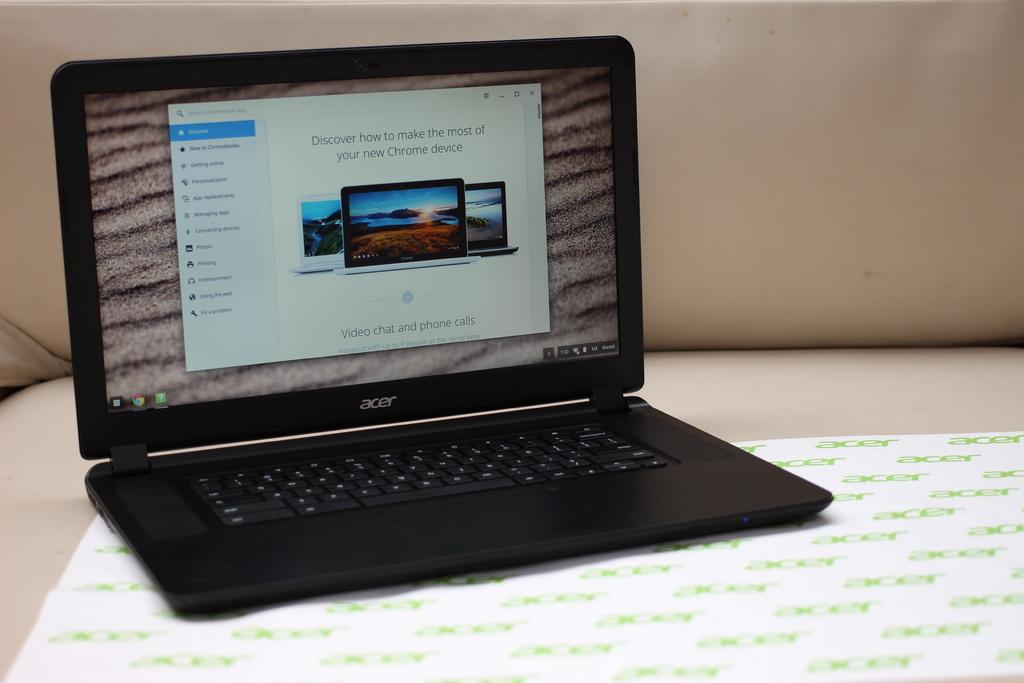Provide a one-sentence caption for the provided image. An Acer laptop that is open to a page where you can discover how to make the most of your new Chrome device. 